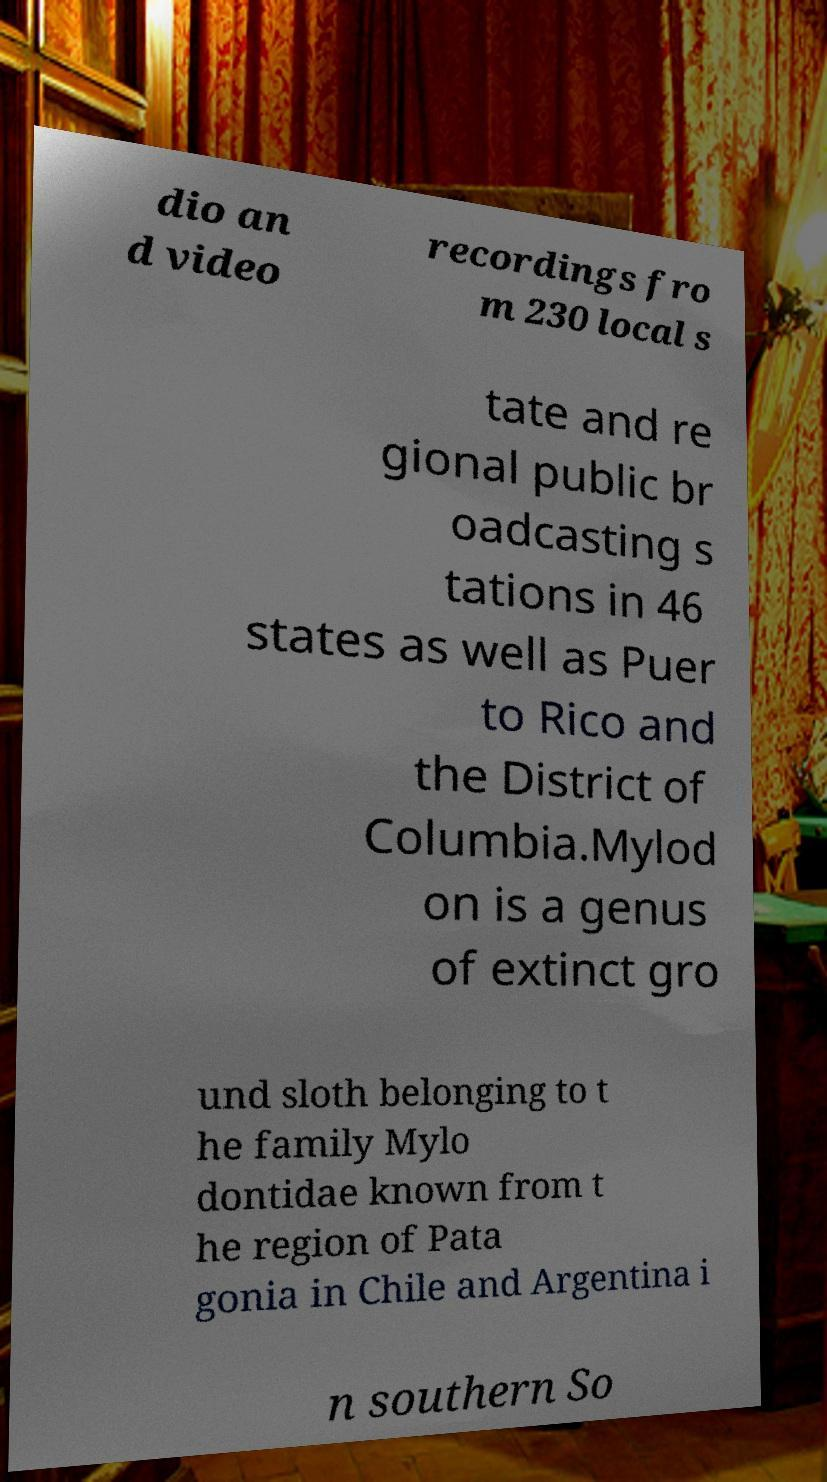There's text embedded in this image that I need extracted. Can you transcribe it verbatim? dio an d video recordings fro m 230 local s tate and re gional public br oadcasting s tations in 46 states as well as Puer to Rico and the District of Columbia.Mylod on is a genus of extinct gro und sloth belonging to t he family Mylo dontidae known from t he region of Pata gonia in Chile and Argentina i n southern So 